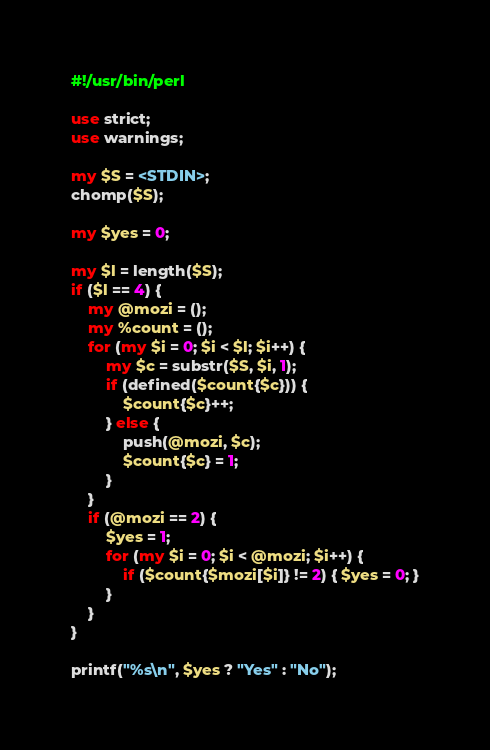Convert code to text. <code><loc_0><loc_0><loc_500><loc_500><_Perl_>#!/usr/bin/perl

use strict;
use warnings;

my $S = <STDIN>;
chomp($S);

my $yes = 0;

my $l = length($S);
if ($l == 4) {
	my @mozi = ();
	my %count = ();
	for (my $i = 0; $i < $l; $i++) {
		my $c = substr($S, $i, 1);
		if (defined($count{$c})) {
			$count{$c}++;
		} else {
			push(@mozi, $c);
			$count{$c} = 1;
		}
	}
	if (@mozi == 2) {
		$yes = 1;
		for (my $i = 0; $i < @mozi; $i++) {
			if ($count{$mozi[$i]} != 2) { $yes = 0; }
		}
	}
}

printf("%s\n", $yes ? "Yes" : "No");
</code> 